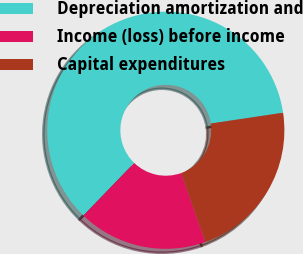Convert chart to OTSL. <chart><loc_0><loc_0><loc_500><loc_500><pie_chart><fcel>Depreciation amortization and<fcel>Income (loss) before income<fcel>Capital expenditures<nl><fcel>60.41%<fcel>17.66%<fcel>21.93%<nl></chart> 